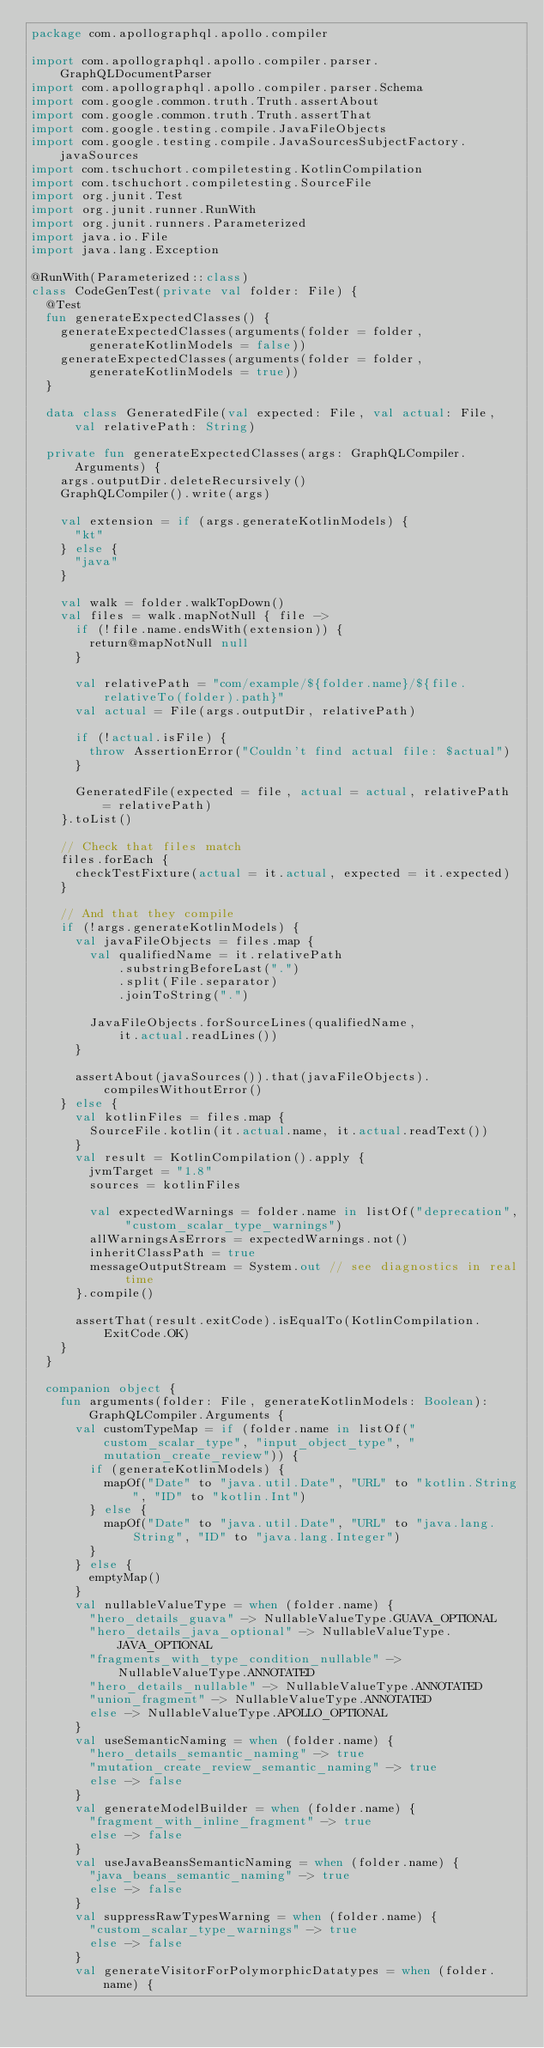Convert code to text. <code><loc_0><loc_0><loc_500><loc_500><_Kotlin_>package com.apollographql.apollo.compiler

import com.apollographql.apollo.compiler.parser.GraphQLDocumentParser
import com.apollographql.apollo.compiler.parser.Schema
import com.google.common.truth.Truth.assertAbout
import com.google.common.truth.Truth.assertThat
import com.google.testing.compile.JavaFileObjects
import com.google.testing.compile.JavaSourcesSubjectFactory.javaSources
import com.tschuchort.compiletesting.KotlinCompilation
import com.tschuchort.compiletesting.SourceFile
import org.junit.Test
import org.junit.runner.RunWith
import org.junit.runners.Parameterized
import java.io.File
import java.lang.Exception

@RunWith(Parameterized::class)
class CodeGenTest(private val folder: File) {
  @Test
  fun generateExpectedClasses() {
    generateExpectedClasses(arguments(folder = folder, generateKotlinModels = false))
    generateExpectedClasses(arguments(folder = folder, generateKotlinModels = true))
  }

  data class GeneratedFile(val expected: File, val actual: File, val relativePath: String)

  private fun generateExpectedClasses(args: GraphQLCompiler.Arguments) {
    args.outputDir.deleteRecursively()
    GraphQLCompiler().write(args)

    val extension = if (args.generateKotlinModels) {
      "kt"
    } else {
      "java"
    }

    val walk = folder.walkTopDown()
    val files = walk.mapNotNull { file ->
      if (!file.name.endsWith(extension)) {
        return@mapNotNull null
      }

      val relativePath = "com/example/${folder.name}/${file.relativeTo(folder).path}"
      val actual = File(args.outputDir, relativePath)

      if (!actual.isFile) {
        throw AssertionError("Couldn't find actual file: $actual")
      }

      GeneratedFile(expected = file, actual = actual, relativePath = relativePath)
    }.toList()

    // Check that files match
    files.forEach {
      checkTestFixture(actual = it.actual, expected = it.expected)
    }

    // And that they compile
    if (!args.generateKotlinModels) {
      val javaFileObjects = files.map {
        val qualifiedName = it.relativePath
            .substringBeforeLast(".")
            .split(File.separator)
            .joinToString(".")

        JavaFileObjects.forSourceLines(qualifiedName,
            it.actual.readLines())
      }

      assertAbout(javaSources()).that(javaFileObjects).compilesWithoutError()
    } else {
      val kotlinFiles = files.map {
        SourceFile.kotlin(it.actual.name, it.actual.readText())
      }
      val result = KotlinCompilation().apply {
        jvmTarget = "1.8"
        sources = kotlinFiles

        val expectedWarnings = folder.name in listOf("deprecation", "custom_scalar_type_warnings")
        allWarningsAsErrors = expectedWarnings.not()
        inheritClassPath = true
        messageOutputStream = System.out // see diagnostics in real time
      }.compile()

      assertThat(result.exitCode).isEqualTo(KotlinCompilation.ExitCode.OK)
    }
  }

  companion object {
    fun arguments(folder: File, generateKotlinModels: Boolean): GraphQLCompiler.Arguments {
      val customTypeMap = if (folder.name in listOf("custom_scalar_type", "input_object_type", "mutation_create_review")) {
        if (generateKotlinModels) {
          mapOf("Date" to "java.util.Date", "URL" to "kotlin.String", "ID" to "kotlin.Int")
        } else {
          mapOf("Date" to "java.util.Date", "URL" to "java.lang.String", "ID" to "java.lang.Integer")
        }
      } else {
        emptyMap()
      }
      val nullableValueType = when (folder.name) {
        "hero_details_guava" -> NullableValueType.GUAVA_OPTIONAL
        "hero_details_java_optional" -> NullableValueType.JAVA_OPTIONAL
        "fragments_with_type_condition_nullable" -> NullableValueType.ANNOTATED
        "hero_details_nullable" -> NullableValueType.ANNOTATED
        "union_fragment" -> NullableValueType.ANNOTATED
        else -> NullableValueType.APOLLO_OPTIONAL
      }
      val useSemanticNaming = when (folder.name) {
        "hero_details_semantic_naming" -> true
        "mutation_create_review_semantic_naming" -> true
        else -> false
      }
      val generateModelBuilder = when (folder.name) {
        "fragment_with_inline_fragment" -> true
        else -> false
      }
      val useJavaBeansSemanticNaming = when (folder.name) {
        "java_beans_semantic_naming" -> true
        else -> false
      }
      val suppressRawTypesWarning = when (folder.name) {
        "custom_scalar_type_warnings" -> true
        else -> false
      }
      val generateVisitorForPolymorphicDatatypes = when (folder.name) {</code> 